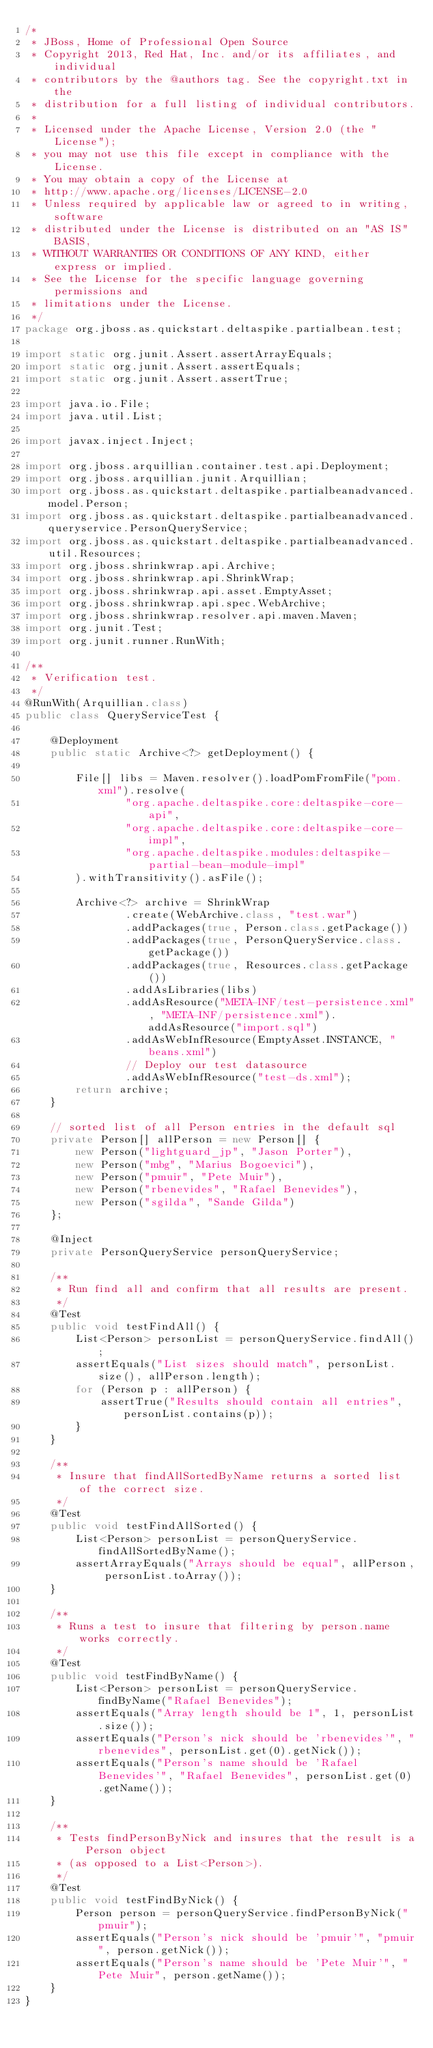Convert code to text. <code><loc_0><loc_0><loc_500><loc_500><_Java_>/*
 * JBoss, Home of Professional Open Source
 * Copyright 2013, Red Hat, Inc. and/or its affiliates, and individual
 * contributors by the @authors tag. See the copyright.txt in the
 * distribution for a full listing of individual contributors.
 *
 * Licensed under the Apache License, Version 2.0 (the "License");
 * you may not use this file except in compliance with the License.
 * You may obtain a copy of the License at
 * http://www.apache.org/licenses/LICENSE-2.0
 * Unless required by applicable law or agreed to in writing, software
 * distributed under the License is distributed on an "AS IS" BASIS,
 * WITHOUT WARRANTIES OR CONDITIONS OF ANY KIND, either express or implied.
 * See the License for the specific language governing permissions and
 * limitations under the License.
 */
package org.jboss.as.quickstart.deltaspike.partialbean.test;

import static org.junit.Assert.assertArrayEquals;
import static org.junit.Assert.assertEquals;
import static org.junit.Assert.assertTrue;

import java.io.File;
import java.util.List;

import javax.inject.Inject;

import org.jboss.arquillian.container.test.api.Deployment;
import org.jboss.arquillian.junit.Arquillian;
import org.jboss.as.quickstart.deltaspike.partialbeanadvanced.model.Person;
import org.jboss.as.quickstart.deltaspike.partialbeanadvanced.queryservice.PersonQueryService;
import org.jboss.as.quickstart.deltaspike.partialbeanadvanced.util.Resources;
import org.jboss.shrinkwrap.api.Archive;
import org.jboss.shrinkwrap.api.ShrinkWrap;
import org.jboss.shrinkwrap.api.asset.EmptyAsset;
import org.jboss.shrinkwrap.api.spec.WebArchive;
import org.jboss.shrinkwrap.resolver.api.maven.Maven;
import org.junit.Test;
import org.junit.runner.RunWith;

/**
 * Verification test.
 */
@RunWith(Arquillian.class)
public class QueryServiceTest {

    @Deployment
    public static Archive<?> getDeployment() {

        File[] libs = Maven.resolver().loadPomFromFile("pom.xml").resolve(
                "org.apache.deltaspike.core:deltaspike-core-api", 
                "org.apache.deltaspike.core:deltaspike-core-impl",
                "org.apache.deltaspike.modules:deltaspike-partial-bean-module-impl"
        ).withTransitivity().asFile();

        Archive<?> archive = ShrinkWrap
                .create(WebArchive.class, "test.war")
                .addPackages(true, Person.class.getPackage())
                .addPackages(true, PersonQueryService.class.getPackage())
                .addPackages(true, Resources.class.getPackage())
                .addAsLibraries(libs)
                .addAsResource("META-INF/test-persistence.xml", "META-INF/persistence.xml").addAsResource("import.sql")
                .addAsWebInfResource(EmptyAsset.INSTANCE, "beans.xml")
                // Deploy our test datasource
                .addAsWebInfResource("test-ds.xml");
        return archive;
    }

    // sorted list of all Person entries in the default sql
    private Person[] allPerson = new Person[] {
        new Person("lightguard_jp", "Jason Porter"),
        new Person("mbg", "Marius Bogoevici"),
        new Person("pmuir", "Pete Muir"),
        new Person("rbenevides", "Rafael Benevides"),
        new Person("sgilda", "Sande Gilda")
    };
    
    @Inject
    private PersonQueryService personQueryService;
    
    /**
     * Run find all and confirm that all results are present.
     */
    @Test
    public void testFindAll() {
        List<Person> personList = personQueryService.findAll();
        assertEquals("List sizes should match", personList.size(), allPerson.length);
        for (Person p : allPerson) {
            assertTrue("Results should contain all entries", personList.contains(p));
        }
    }
    
    /**
     * Insure that findAllSortedByName returns a sorted list of the correct size.
     */
    @Test
    public void testFindAllSorted() {
        List<Person> personList = personQueryService.findAllSortedByName();
        assertArrayEquals("Arrays should be equal", allPerson, personList.toArray());
    }

    /**
     * Runs a test to insure that filtering by person.name works correctly.
     */
    @Test
    public void testFindByName() {
        List<Person> personList = personQueryService.findByName("Rafael Benevides");
        assertEquals("Array length should be 1", 1, personList.size());
        assertEquals("Person's nick should be 'rbenevides'", "rbenevides", personList.get(0).getNick());
        assertEquals("Person's name should be 'Rafael Benevides'", "Rafael Benevides", personList.get(0).getName());
    }
    
    /**
     * Tests findPersonByNick and insures that the result is a Person object
     * (as opposed to a List<Person>).
     */
    @Test
    public void testFindByNick() {
        Person person = personQueryService.findPersonByNick("pmuir");
        assertEquals("Person's nick should be 'pmuir'", "pmuir", person.getNick());
        assertEquals("Person's name should be 'Pete Muir'", "Pete Muir", person.getName());
    }
}
</code> 